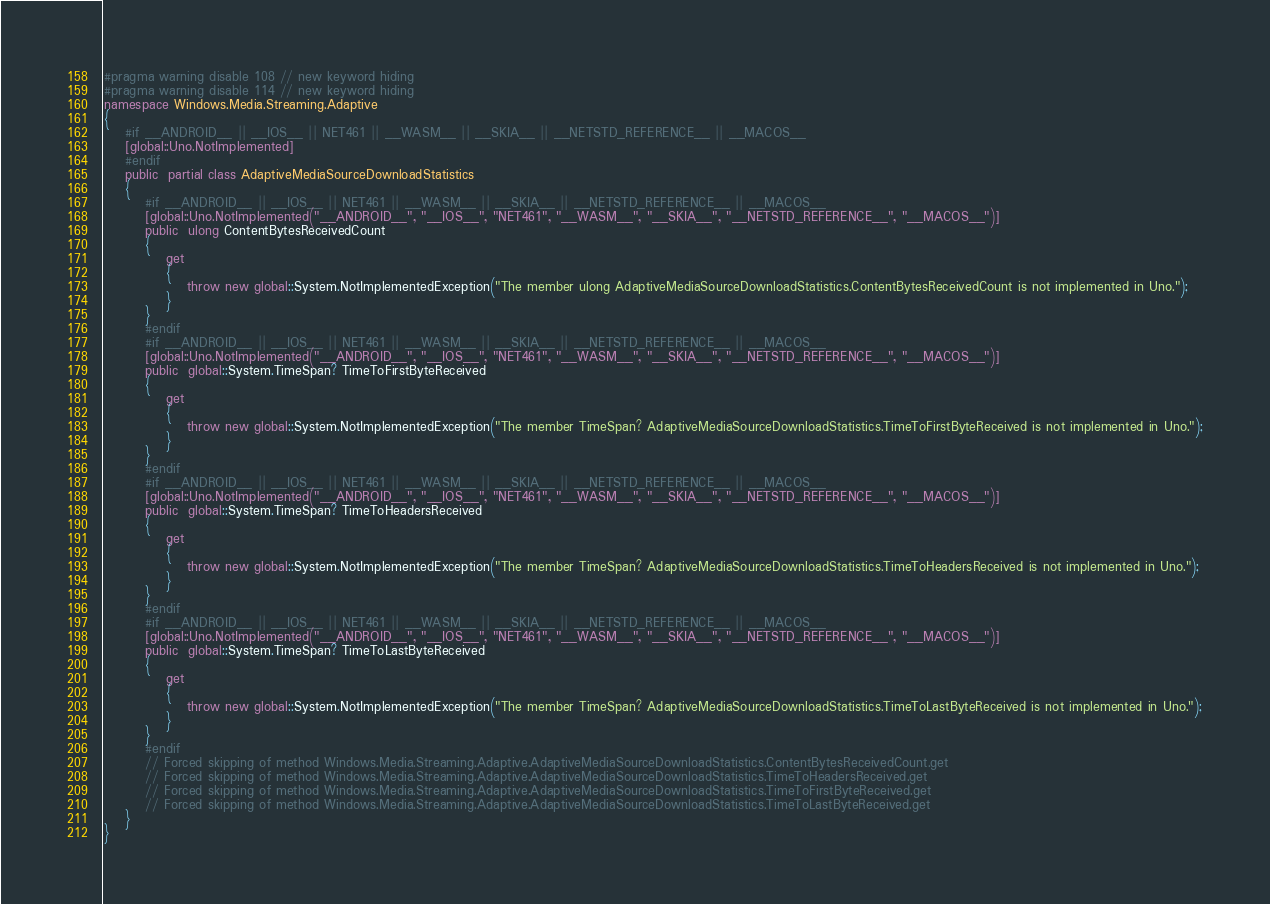Convert code to text. <code><loc_0><loc_0><loc_500><loc_500><_C#_>#pragma warning disable 108 // new keyword hiding
#pragma warning disable 114 // new keyword hiding
namespace Windows.Media.Streaming.Adaptive
{
	#if __ANDROID__ || __IOS__ || NET461 || __WASM__ || __SKIA__ || __NETSTD_REFERENCE__ || __MACOS__
	[global::Uno.NotImplemented]
	#endif
	public  partial class AdaptiveMediaSourceDownloadStatistics 
	{
		#if __ANDROID__ || __IOS__ || NET461 || __WASM__ || __SKIA__ || __NETSTD_REFERENCE__ || __MACOS__
		[global::Uno.NotImplemented("__ANDROID__", "__IOS__", "NET461", "__WASM__", "__SKIA__", "__NETSTD_REFERENCE__", "__MACOS__")]
		public  ulong ContentBytesReceivedCount
		{
			get
			{
				throw new global::System.NotImplementedException("The member ulong AdaptiveMediaSourceDownloadStatistics.ContentBytesReceivedCount is not implemented in Uno.");
			}
		}
		#endif
		#if __ANDROID__ || __IOS__ || NET461 || __WASM__ || __SKIA__ || __NETSTD_REFERENCE__ || __MACOS__
		[global::Uno.NotImplemented("__ANDROID__", "__IOS__", "NET461", "__WASM__", "__SKIA__", "__NETSTD_REFERENCE__", "__MACOS__")]
		public  global::System.TimeSpan? TimeToFirstByteReceived
		{
			get
			{
				throw new global::System.NotImplementedException("The member TimeSpan? AdaptiveMediaSourceDownloadStatistics.TimeToFirstByteReceived is not implemented in Uno.");
			}
		}
		#endif
		#if __ANDROID__ || __IOS__ || NET461 || __WASM__ || __SKIA__ || __NETSTD_REFERENCE__ || __MACOS__
		[global::Uno.NotImplemented("__ANDROID__", "__IOS__", "NET461", "__WASM__", "__SKIA__", "__NETSTD_REFERENCE__", "__MACOS__")]
		public  global::System.TimeSpan? TimeToHeadersReceived
		{
			get
			{
				throw new global::System.NotImplementedException("The member TimeSpan? AdaptiveMediaSourceDownloadStatistics.TimeToHeadersReceived is not implemented in Uno.");
			}
		}
		#endif
		#if __ANDROID__ || __IOS__ || NET461 || __WASM__ || __SKIA__ || __NETSTD_REFERENCE__ || __MACOS__
		[global::Uno.NotImplemented("__ANDROID__", "__IOS__", "NET461", "__WASM__", "__SKIA__", "__NETSTD_REFERENCE__", "__MACOS__")]
		public  global::System.TimeSpan? TimeToLastByteReceived
		{
			get
			{
				throw new global::System.NotImplementedException("The member TimeSpan? AdaptiveMediaSourceDownloadStatistics.TimeToLastByteReceived is not implemented in Uno.");
			}
		}
		#endif
		// Forced skipping of method Windows.Media.Streaming.Adaptive.AdaptiveMediaSourceDownloadStatistics.ContentBytesReceivedCount.get
		// Forced skipping of method Windows.Media.Streaming.Adaptive.AdaptiveMediaSourceDownloadStatistics.TimeToHeadersReceived.get
		// Forced skipping of method Windows.Media.Streaming.Adaptive.AdaptiveMediaSourceDownloadStatistics.TimeToFirstByteReceived.get
		// Forced skipping of method Windows.Media.Streaming.Adaptive.AdaptiveMediaSourceDownloadStatistics.TimeToLastByteReceived.get
	}
}
</code> 